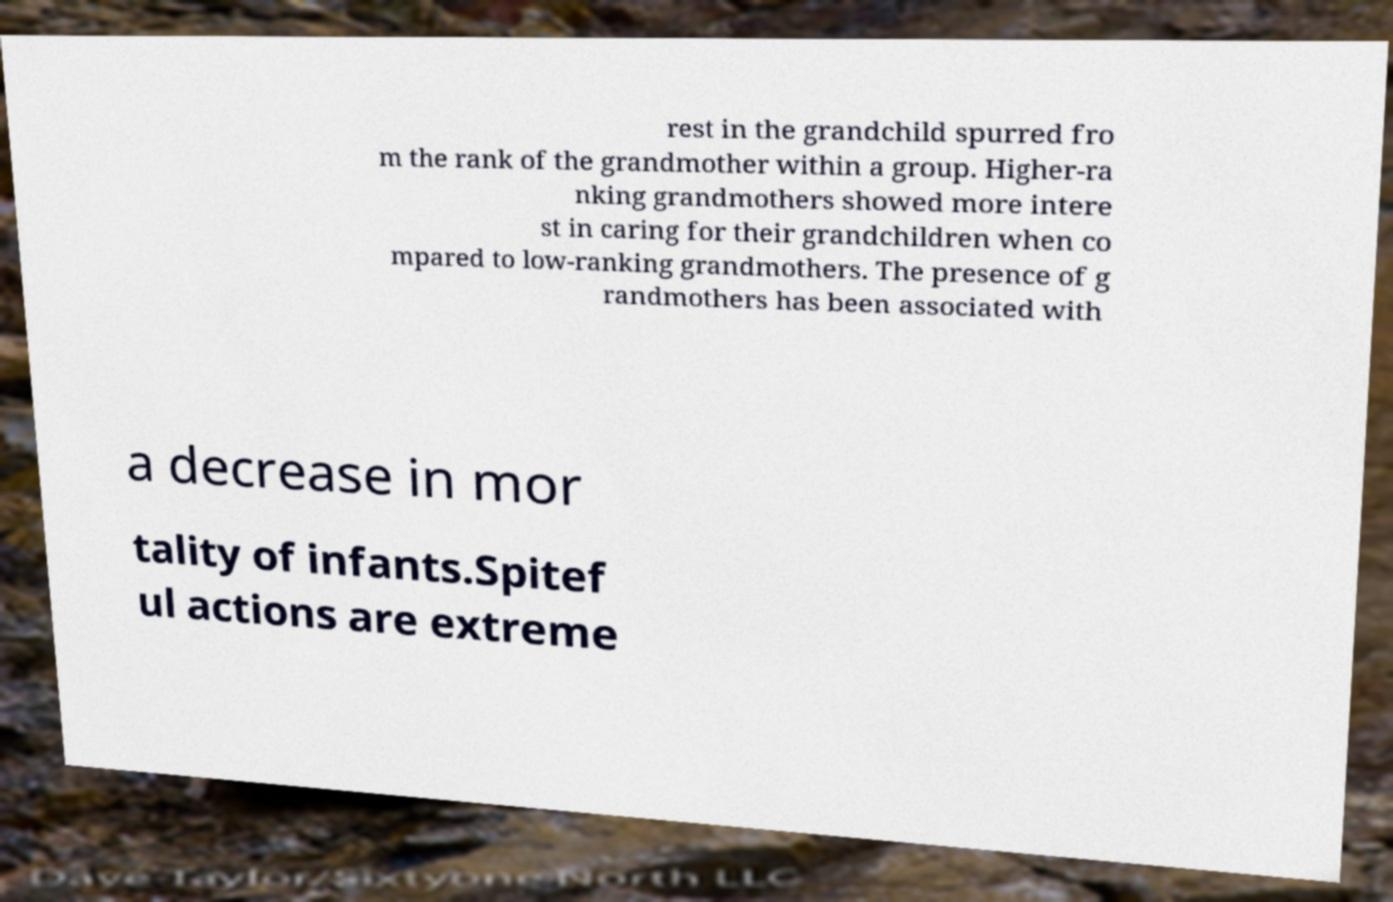Please identify and transcribe the text found in this image. rest in the grandchild spurred fro m the rank of the grandmother within a group. Higher-ra nking grandmothers showed more intere st in caring for their grandchildren when co mpared to low-ranking grandmothers. The presence of g randmothers has been associated with a decrease in mor tality of infants.Spitef ul actions are extreme 